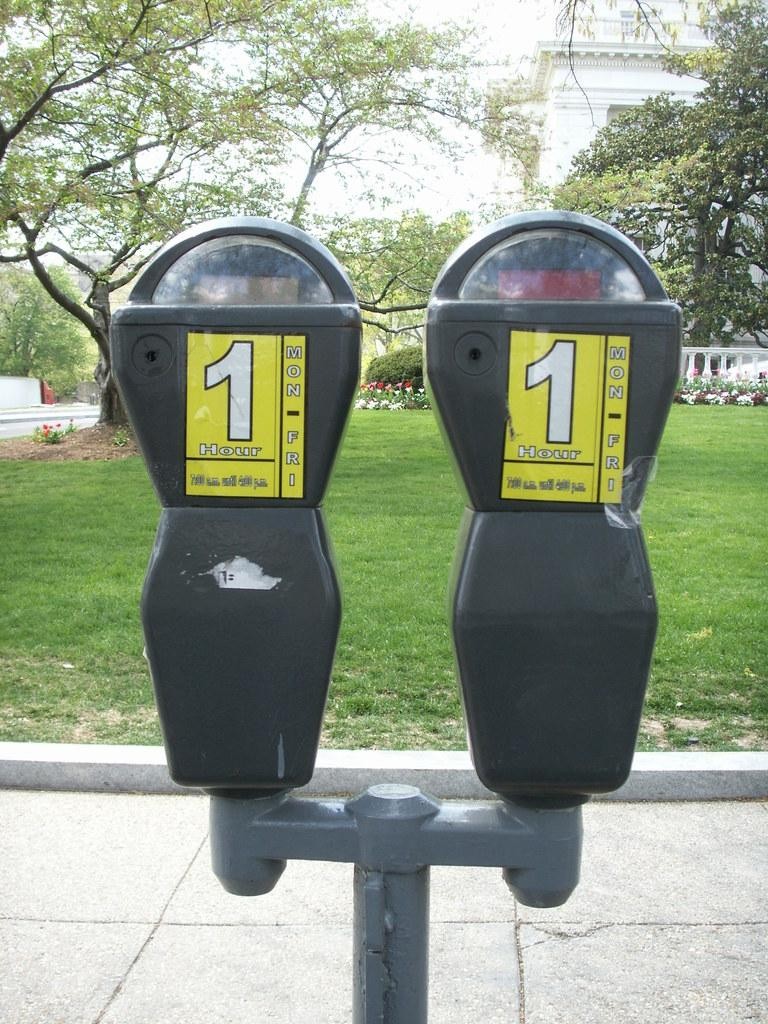<image>
Present a compact description of the photo's key features. Two parking meters with 1 hour yellow stickers. 